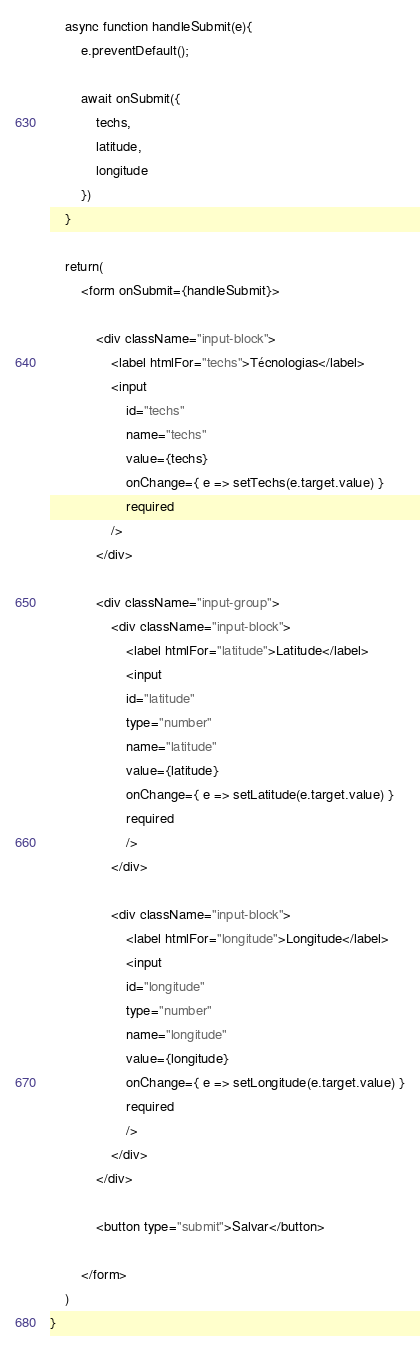Convert code to text. <code><loc_0><loc_0><loc_500><loc_500><_JavaScript_>
    async function handleSubmit(e){
        e.preventDefault();

        await onSubmit({
            techs,
            latitude,
            longitude
        })
    }

    return(
        <form onSubmit={handleSubmit}>

            <div className="input-block">
                <label htmlFor="techs">Técnologias</label>
                <input
                    id="techs"
                    name="techs"
                    value={techs}
                    onChange={ e => setTechs(e.target.value) }
                    required
                />
            </div>

            <div className="input-group">
                <div className="input-block">
                    <label htmlFor="latitude">Latitude</label>
                    <input
                    id="latitude"
                    type="number"
                    name="latitude"
                    value={latitude}
                    onChange={ e => setLatitude(e.target.value) }
                    required
                    />
                </div>

                <div className="input-block">
                    <label htmlFor="longitude">Longitude</label>
                    <input
                    id="longitude"
                    type="number"
                    name="longitude"
                    value={longitude} 
                    onChange={ e => setLongitude(e.target.value) }
                    required
                    />
                </div>
            </div>

            <button type="submit">Salvar</button>

        </form>
    )
}</code> 